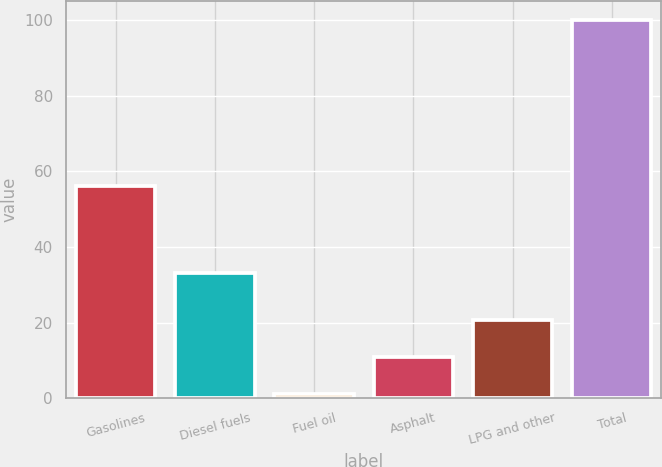Convert chart to OTSL. <chart><loc_0><loc_0><loc_500><loc_500><bar_chart><fcel>Gasolines<fcel>Diesel fuels<fcel>Fuel oil<fcel>Asphalt<fcel>LPG and other<fcel>Total<nl><fcel>56<fcel>33<fcel>1<fcel>10.9<fcel>20.8<fcel>100<nl></chart> 